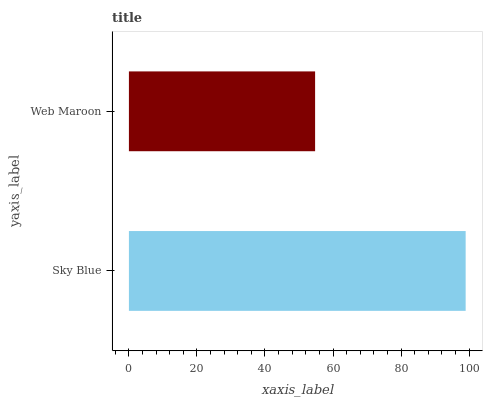Is Web Maroon the minimum?
Answer yes or no. Yes. Is Sky Blue the maximum?
Answer yes or no. Yes. Is Web Maroon the maximum?
Answer yes or no. No. Is Sky Blue greater than Web Maroon?
Answer yes or no. Yes. Is Web Maroon less than Sky Blue?
Answer yes or no. Yes. Is Web Maroon greater than Sky Blue?
Answer yes or no. No. Is Sky Blue less than Web Maroon?
Answer yes or no. No. Is Sky Blue the high median?
Answer yes or no. Yes. Is Web Maroon the low median?
Answer yes or no. Yes. Is Web Maroon the high median?
Answer yes or no. No. Is Sky Blue the low median?
Answer yes or no. No. 